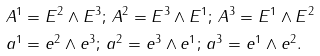<formula> <loc_0><loc_0><loc_500><loc_500>A ^ { 1 } & = E ^ { 2 } \wedge E ^ { 3 } ; \, A ^ { 2 } = E ^ { 3 } \wedge E ^ { 1 } ; \, A ^ { 3 } = E ^ { 1 } \wedge E ^ { 2 } \\ a ^ { 1 } & = e ^ { 2 } \wedge e ^ { 3 } ; \, a ^ { 2 } = e ^ { 3 } \wedge e ^ { 1 } ; \, a ^ { 3 } = e ^ { 1 } \wedge e ^ { 2 } .</formula> 